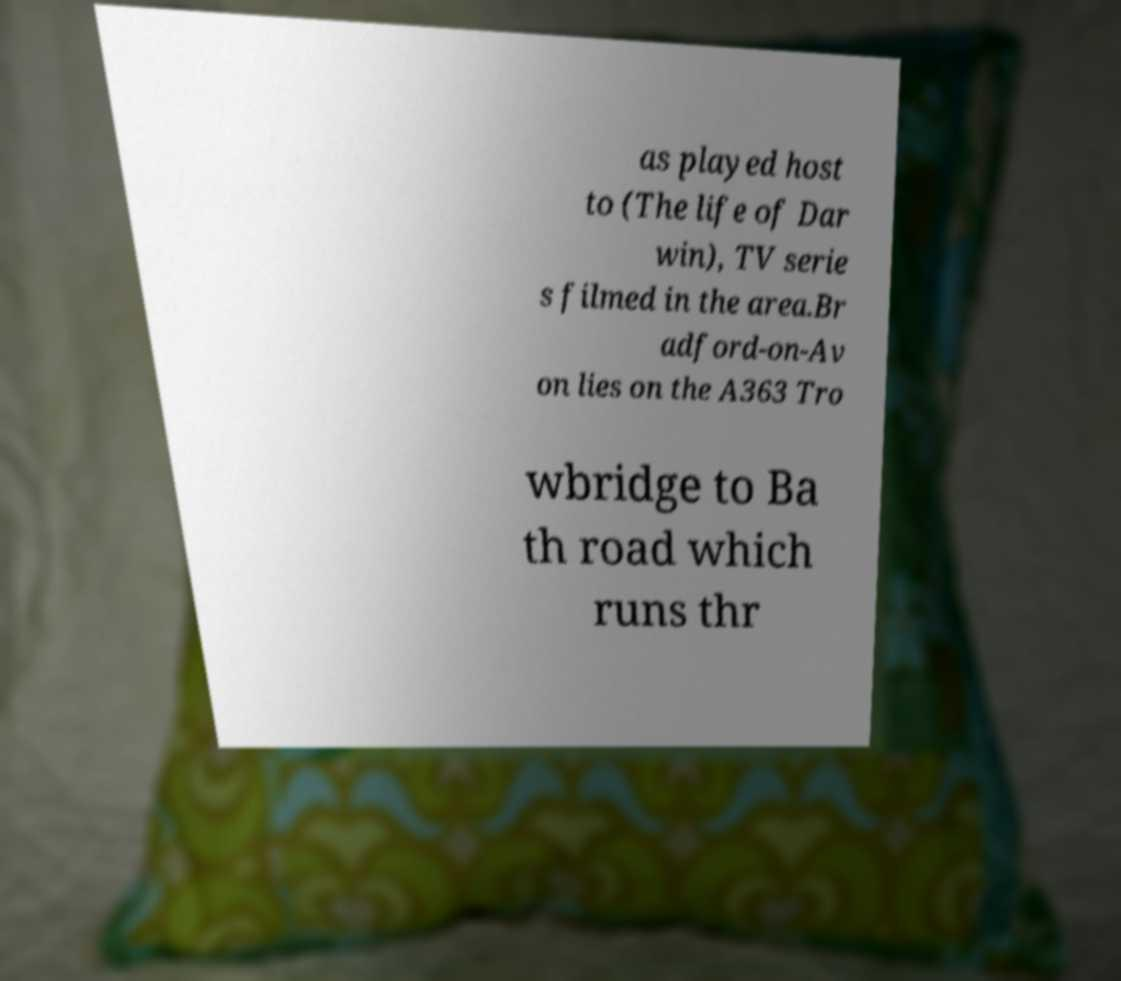There's text embedded in this image that I need extracted. Can you transcribe it verbatim? as played host to (The life of Dar win), TV serie s filmed in the area.Br adford-on-Av on lies on the A363 Tro wbridge to Ba th road which runs thr 